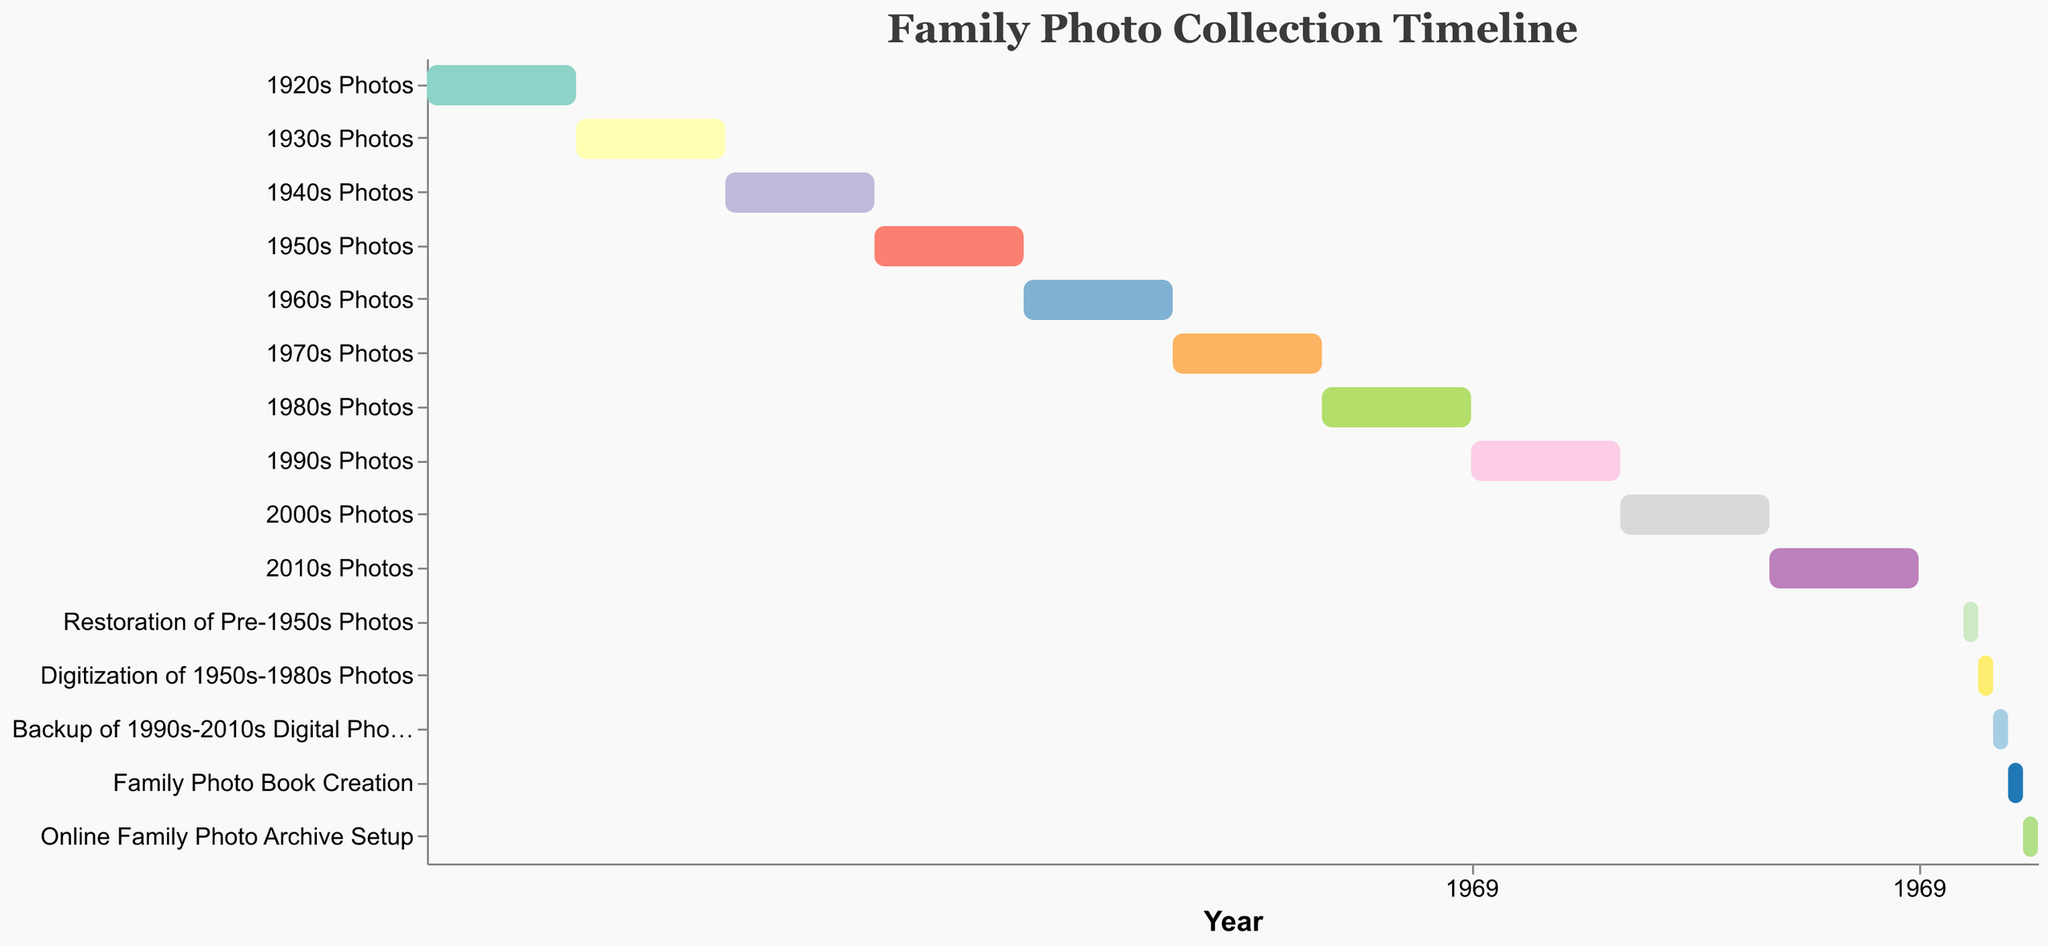What's the title of the chart? The title is located at the top of the chart and is often the largest text, distinct from other labels and axis titles. In this chart, the title reads "Family Photo Collection Timeline".
Answer: Family Photo Collection Timeline Which decade's photo set is scheduled first for restoration? To determine this, look for the first restoration task that falls after the initial decades of photos. The task "Restoration of Pre-1950s Photos" starts in 2023.
Answer: Pre-1950s Photos When will the digitization of 1950s-1980s Photos start and end? Find the bar labeled "Digitization of 1950s-1980s Photos" in the y-axis and then look at its start and end points on the x-axis. The bar starts at 2024 and ends at 2025.
Answer: 2024-2025 What's the total span of years covered by the photos from the 1920s to the 2010s? The first photo set starts in 1920 and the last one ends in 2020. Subtract 1920 from 2020 to get the total span of 100 years.
Answer: 100 years Which restoration or digitization task will last the longest? By comparing the lengths of the bars for the tasks labeled as restoration or digitization, we see that each task (Restoration, Digitization, Backup, Creation, Setup) lasts about one year each.
Answer: All tasks last one year each What is the sequence of preservation tasks after 2023? Observe the bars labeled with tasks such as restoration or digitization after 2023. The sequence is "Restoration of Pre-1950s Photos" (2023-2024), "Digitization of 1950s-1980s Photos" (2024-2025), "Backup of 1990s-2010s Digital Photos" (2025-2026), "Family Photo Book Creation" (2026-2027), and "Online Family Photo Archive Setup" (2027-2028).
Answer: Restoration, Digitization, Backup, Creation, Setup From which decade to which decade are the photos being digitized? Look for the task "Digitization of 1950s-1980s Photos", indicating it spans from the 1950s to the 1980s.
Answer: 1950s-1980s 